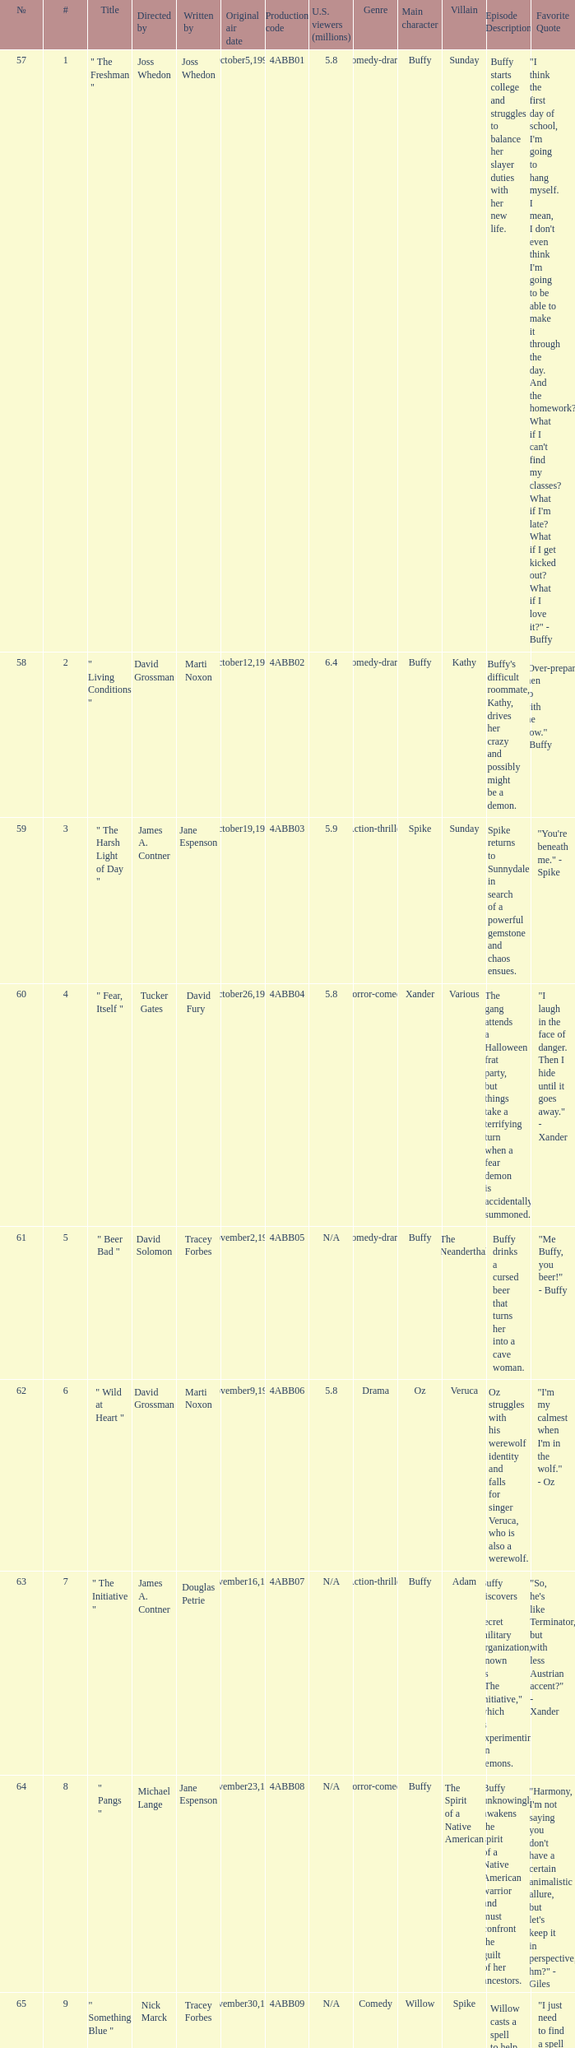Who wrote the episode which was directed by Nick Marck? Tracey Forbes. 